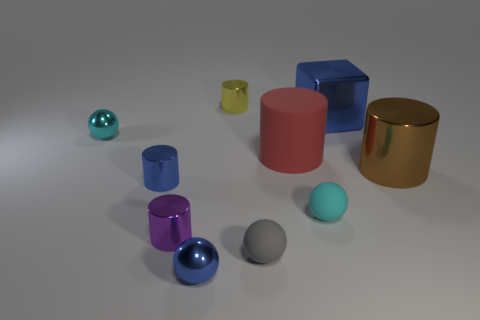Do the large red thing and the small purple object have the same shape?
Make the answer very short. Yes. How many other objects are there of the same size as the yellow metal thing?
Your response must be concise. 6. What number of objects are either tiny metal things in front of the big blue object or small red cubes?
Your response must be concise. 4. The big rubber cylinder has what color?
Your answer should be compact. Red. There is a large cylinder on the left side of the brown object; what is it made of?
Ensure brevity in your answer.  Rubber. There is a yellow shiny thing; is it the same shape as the cyan thing behind the large brown object?
Provide a short and direct response. No. Are there more large green cubes than small blue metal balls?
Make the answer very short. No. Is there anything else that is the same color as the big cube?
Your response must be concise. Yes. The gray thing that is made of the same material as the big red cylinder is what shape?
Keep it short and to the point. Sphere. What is the cylinder in front of the small matte ball that is on the right side of the big red thing made of?
Ensure brevity in your answer.  Metal. 